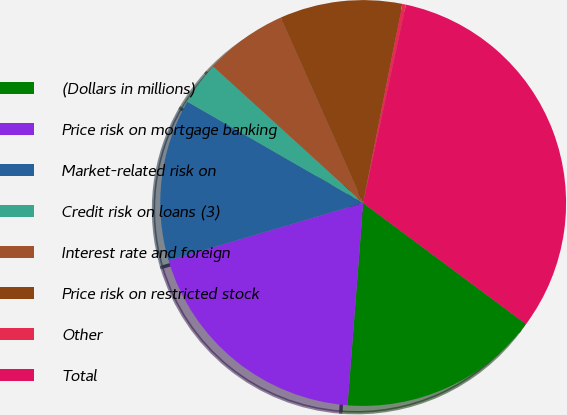Convert chart to OTSL. <chart><loc_0><loc_0><loc_500><loc_500><pie_chart><fcel>(Dollars in millions)<fcel>Price risk on mortgage banking<fcel>Market-related risk on<fcel>Credit risk on loans (3)<fcel>Interest rate and foreign<fcel>Price risk on restricted stock<fcel>Other<fcel>Total<nl><fcel>16.05%<fcel>19.2%<fcel>12.89%<fcel>3.44%<fcel>6.59%<fcel>9.74%<fcel>0.29%<fcel>31.8%<nl></chart> 